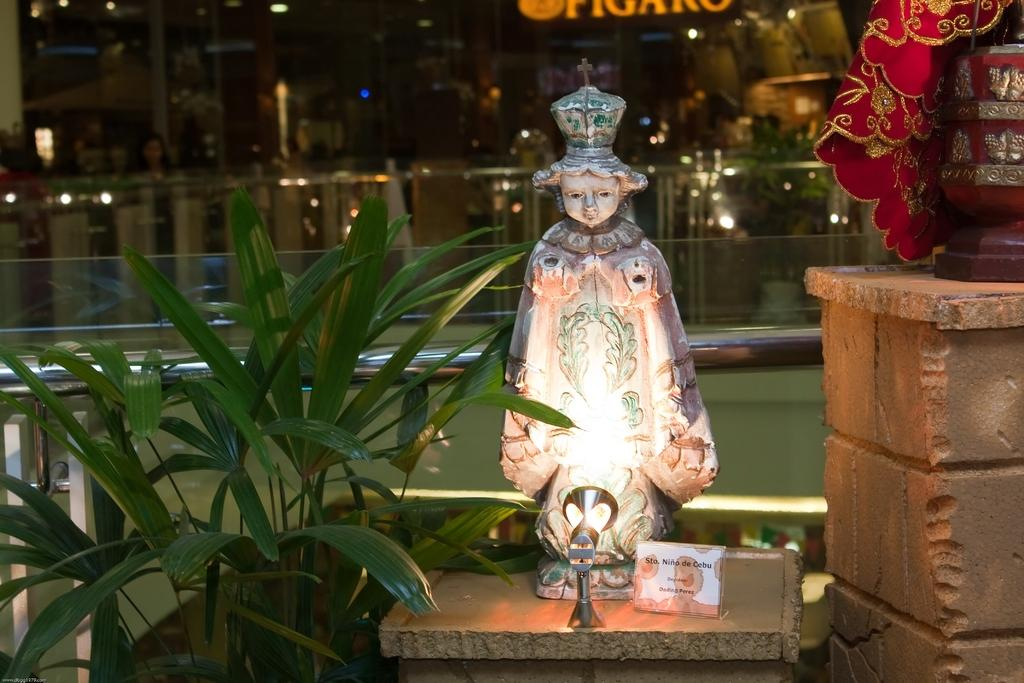What is placed on the table in the image? There is a statue on the table in the image. Can you describe the lighting in the image? There is a light and lights visible in the image. What is present to identify the statue or the person seated? There is a small name plate in the image. What type of vegetation is present in the image? There are plants in the image. What is the human seated doing in the image? There is a human seated in the image, but their activity is not specified. What is written or displayed on the board in the image? There is a board with some text in the image. Can you tell me how many seeds are visible in the image? There are no seeds present in the image. What type of apple is being used as a paperweight in the image? There is no apple present in the image. 